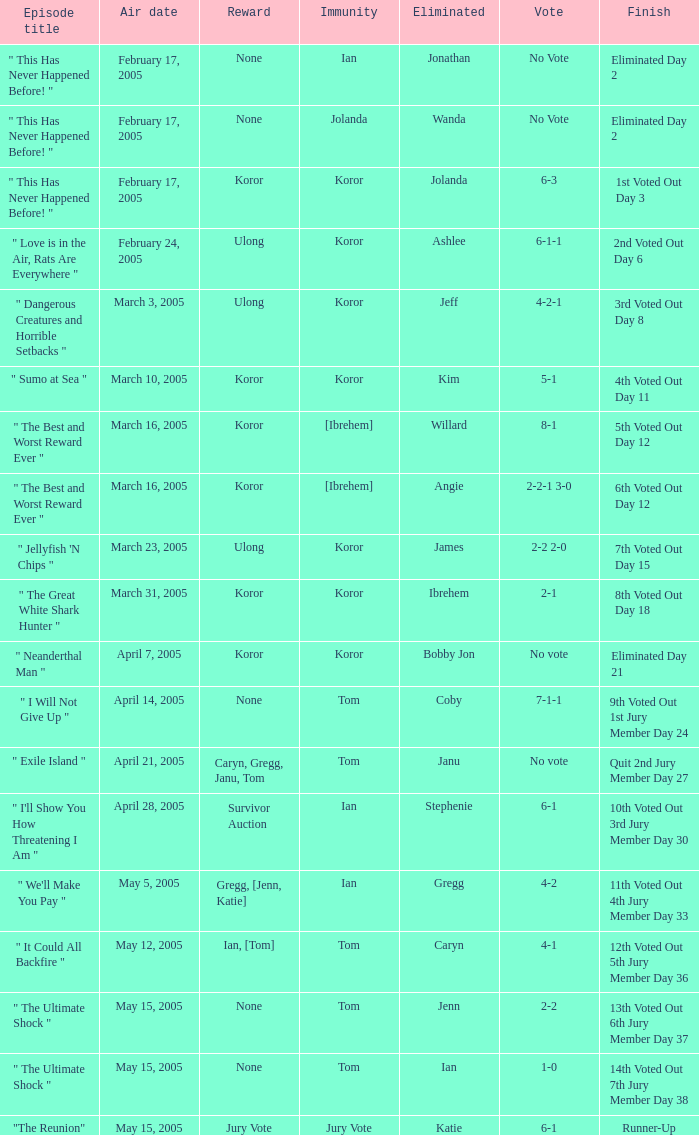What was the outcome of the vote in the episode where the result was "10th voted out, 3rd jury member, day 30"? 6-1. Can you give me this table as a dict? {'header': ['Episode title', 'Air date', 'Reward', 'Immunity', 'Eliminated', 'Vote', 'Finish'], 'rows': [['" This Has Never Happened Before! "', 'February 17, 2005', 'None', 'Ian', 'Jonathan', 'No Vote', 'Eliminated Day 2'], ['" This Has Never Happened Before! "', 'February 17, 2005', 'None', 'Jolanda', 'Wanda', 'No Vote', 'Eliminated Day 2'], ['" This Has Never Happened Before! "', 'February 17, 2005', 'Koror', 'Koror', 'Jolanda', '6-3', '1st Voted Out Day 3'], ['" Love is in the Air, Rats Are Everywhere "', 'February 24, 2005', 'Ulong', 'Koror', 'Ashlee', '6-1-1', '2nd Voted Out Day 6'], ['" Dangerous Creatures and Horrible Setbacks "', 'March 3, 2005', 'Ulong', 'Koror', 'Jeff', '4-2-1', '3rd Voted Out Day 8'], ['" Sumo at Sea "', 'March 10, 2005', 'Koror', 'Koror', 'Kim', '5-1', '4th Voted Out Day 11'], ['" The Best and Worst Reward Ever "', 'March 16, 2005', 'Koror', '[Ibrehem]', 'Willard', '8-1', '5th Voted Out Day 12'], ['" The Best and Worst Reward Ever "', 'March 16, 2005', 'Koror', '[Ibrehem]', 'Angie', '2-2-1 3-0', '6th Voted Out Day 12'], ['" Jellyfish \'N Chips "', 'March 23, 2005', 'Ulong', 'Koror', 'James', '2-2 2-0', '7th Voted Out Day 15'], ['" The Great White Shark Hunter "', 'March 31, 2005', 'Koror', 'Koror', 'Ibrehem', '2-1', '8th Voted Out Day 18'], ['" Neanderthal Man "', 'April 7, 2005', 'Koror', 'Koror', 'Bobby Jon', 'No vote', 'Eliminated Day 21'], ['" I Will Not Give Up "', 'April 14, 2005', 'None', 'Tom', 'Coby', '7-1-1', '9th Voted Out 1st Jury Member Day 24'], ['" Exile Island "', 'April 21, 2005', 'Caryn, Gregg, Janu, Tom', 'Tom', 'Janu', 'No vote', 'Quit 2nd Jury Member Day 27'], ['" I\'ll Show You How Threatening I Am "', 'April 28, 2005', 'Survivor Auction', 'Ian', 'Stephenie', '6-1', '10th Voted Out 3rd Jury Member Day 30'], ['" We\'ll Make You Pay "', 'May 5, 2005', 'Gregg, [Jenn, Katie]', 'Ian', 'Gregg', '4-2', '11th Voted Out 4th Jury Member Day 33'], ['" It Could All Backfire "', 'May 12, 2005', 'Ian, [Tom]', 'Tom', 'Caryn', '4-1', '12th Voted Out 5th Jury Member Day 36'], ['" The Ultimate Shock "', 'May 15, 2005', 'None', 'Tom', 'Jenn', '2-2', '13th Voted Out 6th Jury Member Day 37'], ['" The Ultimate Shock "', 'May 15, 2005', 'None', 'Tom', 'Ian', '1-0', '14th Voted Out 7th Jury Member Day 38'], ['"The Reunion"', 'May 15, 2005', 'Jury Vote', 'Jury Vote', 'Katie', '6-1', 'Runner-Up']]} 